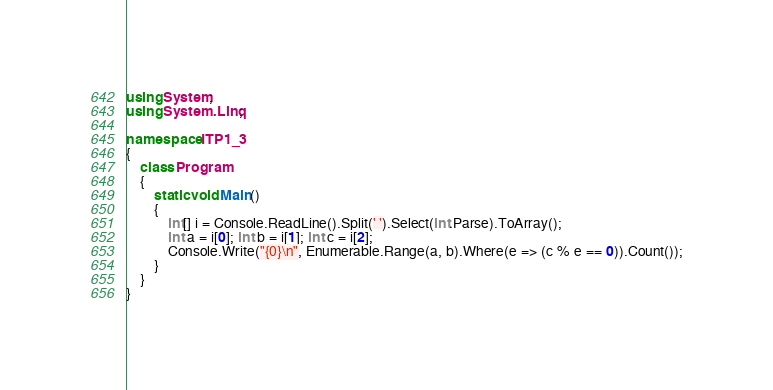<code> <loc_0><loc_0><loc_500><loc_500><_C#_>using System;
using System.Linq;

namespace ITP1_3
{
    class Program
    {
        static void Main()
        {
            int[] i = Console.ReadLine().Split(' ').Select(int.Parse).ToArray();
            int a = i[0]; int b = i[1]; int c = i[2];
            Console.Write("{0}\n", Enumerable.Range(a, b).Where(e => (c % e == 0)).Count());
        }
    }
}</code> 